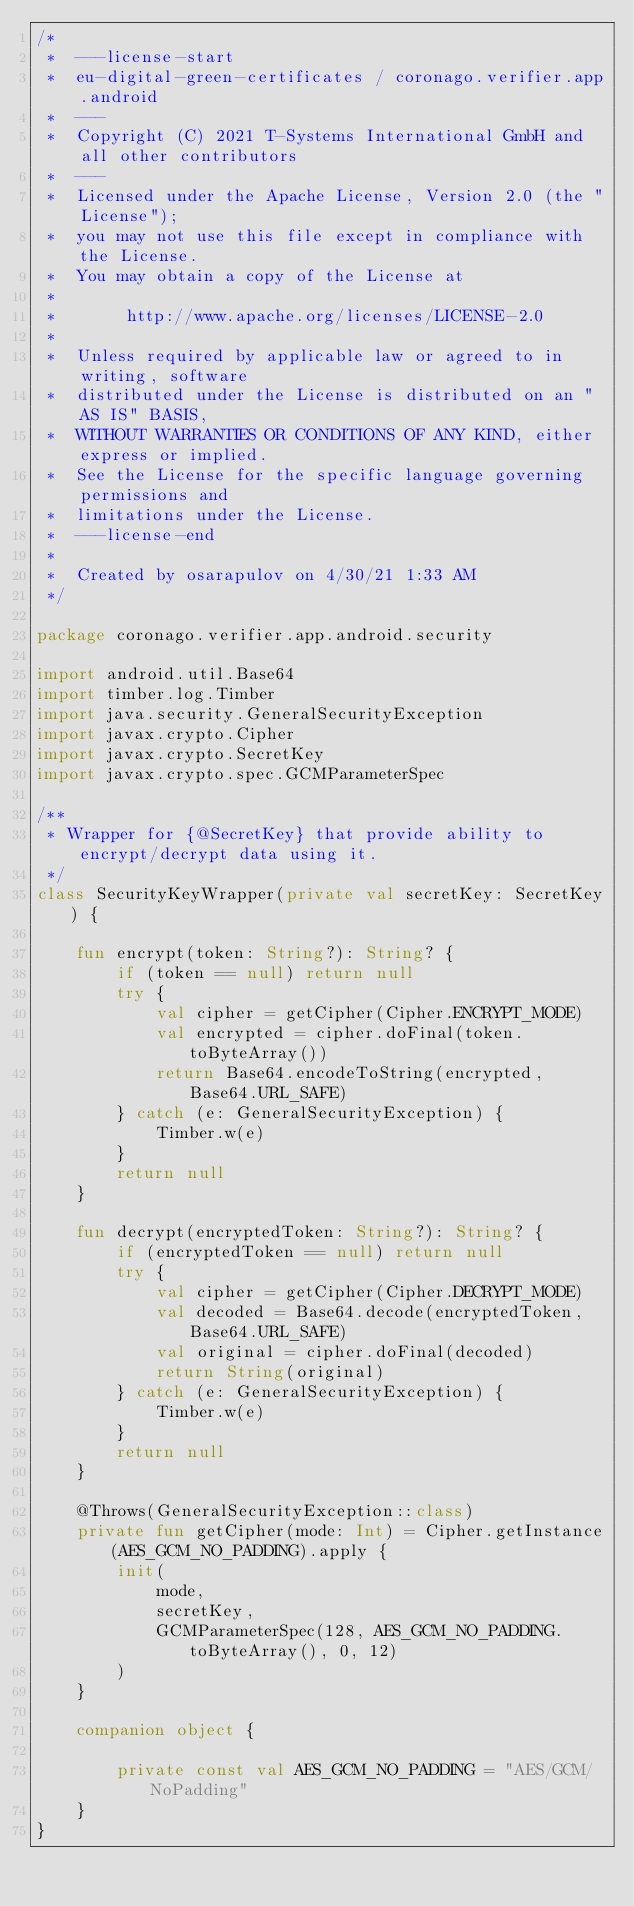<code> <loc_0><loc_0><loc_500><loc_500><_Kotlin_>/*
 *  ---license-start
 *  eu-digital-green-certificates / coronago.verifier.app.android
 *  ---
 *  Copyright (C) 2021 T-Systems International GmbH and all other contributors
 *  ---
 *  Licensed under the Apache License, Version 2.0 (the "License");
 *  you may not use this file except in compliance with the License.
 *  You may obtain a copy of the License at
 *
 *       http://www.apache.org/licenses/LICENSE-2.0
 *
 *  Unless required by applicable law or agreed to in writing, software
 *  distributed under the License is distributed on an "AS IS" BASIS,
 *  WITHOUT WARRANTIES OR CONDITIONS OF ANY KIND, either express or implied.
 *  See the License for the specific language governing permissions and
 *  limitations under the License.
 *  ---license-end
 *
 *  Created by osarapulov on 4/30/21 1:33 AM
 */

package coronago.verifier.app.android.security

import android.util.Base64
import timber.log.Timber
import java.security.GeneralSecurityException
import javax.crypto.Cipher
import javax.crypto.SecretKey
import javax.crypto.spec.GCMParameterSpec

/**
 * Wrapper for {@SecretKey} that provide ability to encrypt/decrypt data using it.
 */
class SecurityKeyWrapper(private val secretKey: SecretKey) {

    fun encrypt(token: String?): String? {
        if (token == null) return null
        try {
            val cipher = getCipher(Cipher.ENCRYPT_MODE)
            val encrypted = cipher.doFinal(token.toByteArray())
            return Base64.encodeToString(encrypted, Base64.URL_SAFE)
        } catch (e: GeneralSecurityException) {
            Timber.w(e)
        }
        return null
    }

    fun decrypt(encryptedToken: String?): String? {
        if (encryptedToken == null) return null
        try {
            val cipher = getCipher(Cipher.DECRYPT_MODE)
            val decoded = Base64.decode(encryptedToken, Base64.URL_SAFE)
            val original = cipher.doFinal(decoded)
            return String(original)
        } catch (e: GeneralSecurityException) {
            Timber.w(e)
        }
        return null
    }

    @Throws(GeneralSecurityException::class)
    private fun getCipher(mode: Int) = Cipher.getInstance(AES_GCM_NO_PADDING).apply {
        init(
            mode,
            secretKey,
            GCMParameterSpec(128, AES_GCM_NO_PADDING.toByteArray(), 0, 12)
        )
    }

    companion object {

        private const val AES_GCM_NO_PADDING = "AES/GCM/NoPadding"
    }
}</code> 